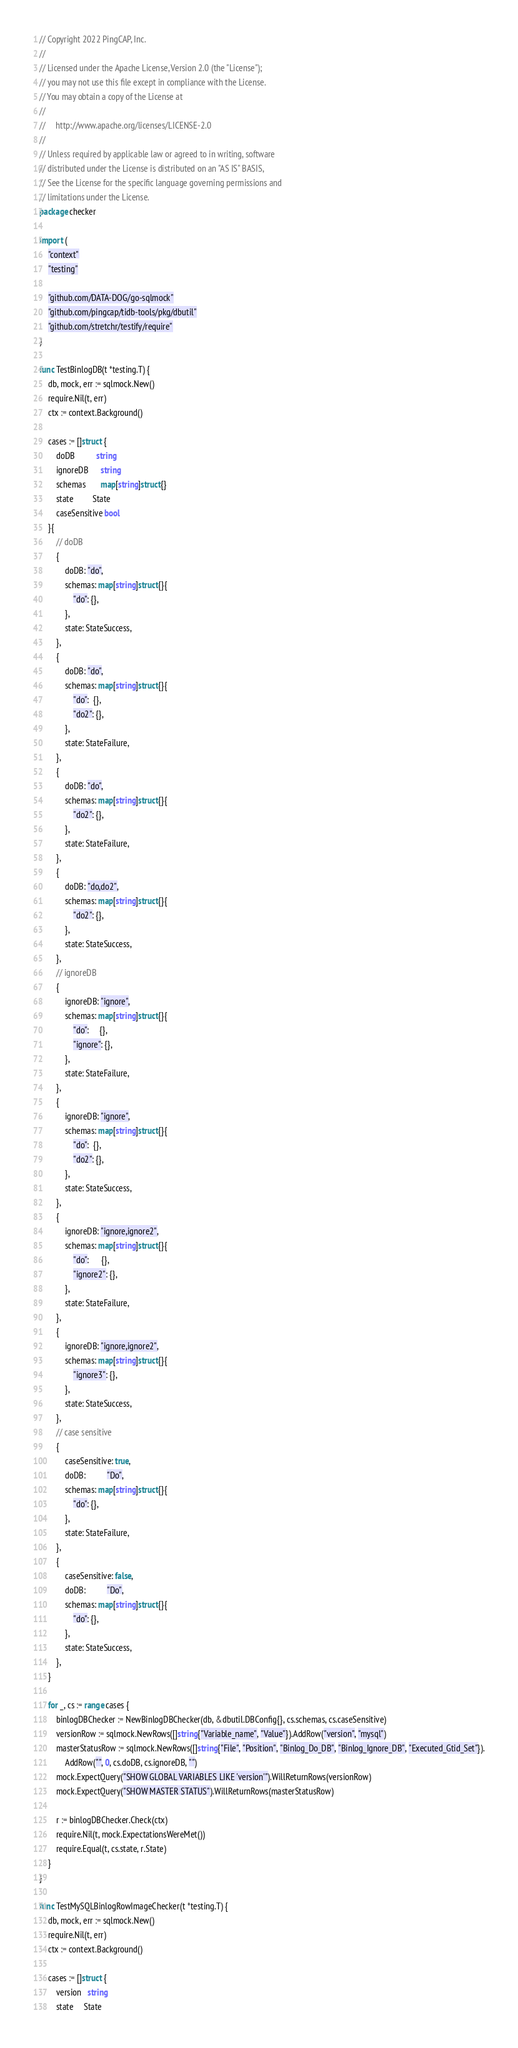Convert code to text. <code><loc_0><loc_0><loc_500><loc_500><_Go_>// Copyright 2022 PingCAP, Inc.
//
// Licensed under the Apache License, Version 2.0 (the "License");
// you may not use this file except in compliance with the License.
// You may obtain a copy of the License at
//
//     http://www.apache.org/licenses/LICENSE-2.0
//
// Unless required by applicable law or agreed to in writing, software
// distributed under the License is distributed on an "AS IS" BASIS,
// See the License for the specific language governing permissions and
// limitations under the License.
package checker

import (
	"context"
	"testing"

	"github.com/DATA-DOG/go-sqlmock"
	"github.com/pingcap/tidb-tools/pkg/dbutil"
	"github.com/stretchr/testify/require"
)

func TestBinlogDB(t *testing.T) {
	db, mock, err := sqlmock.New()
	require.Nil(t, err)
	ctx := context.Background()

	cases := []struct {
		doDB          string
		ignoreDB      string
		schemas       map[string]struct{}
		state         State
		caseSensitive bool
	}{
		// doDB
		{
			doDB: "do",
			schemas: map[string]struct{}{
				"do": {},
			},
			state: StateSuccess,
		},
		{
			doDB: "do",
			schemas: map[string]struct{}{
				"do":  {},
				"do2": {},
			},
			state: StateFailure,
		},
		{
			doDB: "do",
			schemas: map[string]struct{}{
				"do2": {},
			},
			state: StateFailure,
		},
		{
			doDB: "do,do2",
			schemas: map[string]struct{}{
				"do2": {},
			},
			state: StateSuccess,
		},
		// ignoreDB
		{
			ignoreDB: "ignore",
			schemas: map[string]struct{}{
				"do":     {},
				"ignore": {},
			},
			state: StateFailure,
		},
		{
			ignoreDB: "ignore",
			schemas: map[string]struct{}{
				"do":  {},
				"do2": {},
			},
			state: StateSuccess,
		},
		{
			ignoreDB: "ignore,ignore2",
			schemas: map[string]struct{}{
				"do":      {},
				"ignore2": {},
			},
			state: StateFailure,
		},
		{
			ignoreDB: "ignore,ignore2",
			schemas: map[string]struct{}{
				"ignore3": {},
			},
			state: StateSuccess,
		},
		// case sensitive
		{
			caseSensitive: true,
			doDB:          "Do",
			schemas: map[string]struct{}{
				"do": {},
			},
			state: StateFailure,
		},
		{
			caseSensitive: false,
			doDB:          "Do",
			schemas: map[string]struct{}{
				"do": {},
			},
			state: StateSuccess,
		},
	}

	for _, cs := range cases {
		binlogDBChecker := NewBinlogDBChecker(db, &dbutil.DBConfig{}, cs.schemas, cs.caseSensitive)
		versionRow := sqlmock.NewRows([]string{"Variable_name", "Value"}).AddRow("version", "mysql")
		masterStatusRow := sqlmock.NewRows([]string{"File", "Position", "Binlog_Do_DB", "Binlog_Ignore_DB", "Executed_Gtid_Set"}).
			AddRow("", 0, cs.doDB, cs.ignoreDB, "")
		mock.ExpectQuery("SHOW GLOBAL VARIABLES LIKE 'version'").WillReturnRows(versionRow)
		mock.ExpectQuery("SHOW MASTER STATUS").WillReturnRows(masterStatusRow)

		r := binlogDBChecker.Check(ctx)
		require.Nil(t, mock.ExpectationsWereMet())
		require.Equal(t, cs.state, r.State)
	}
}

func TestMySQLBinlogRowImageChecker(t *testing.T) {
	db, mock, err := sqlmock.New()
	require.Nil(t, err)
	ctx := context.Background()

	cases := []struct {
		version   string
		state     State</code> 